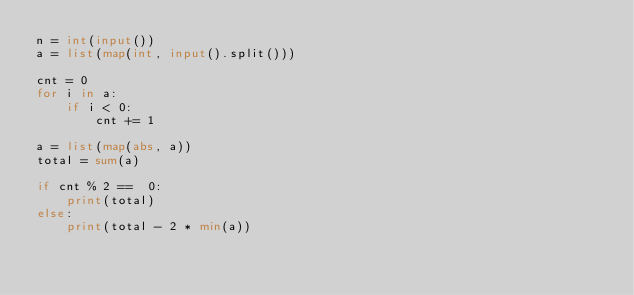Convert code to text. <code><loc_0><loc_0><loc_500><loc_500><_Python_>n = int(input())
a = list(map(int, input().split()))

cnt = 0
for i in a:
    if i < 0:
        cnt += 1

a = list(map(abs, a))
total = sum(a)

if cnt % 2 ==  0:
    print(total)
else:
    print(total - 2 * min(a))
</code> 